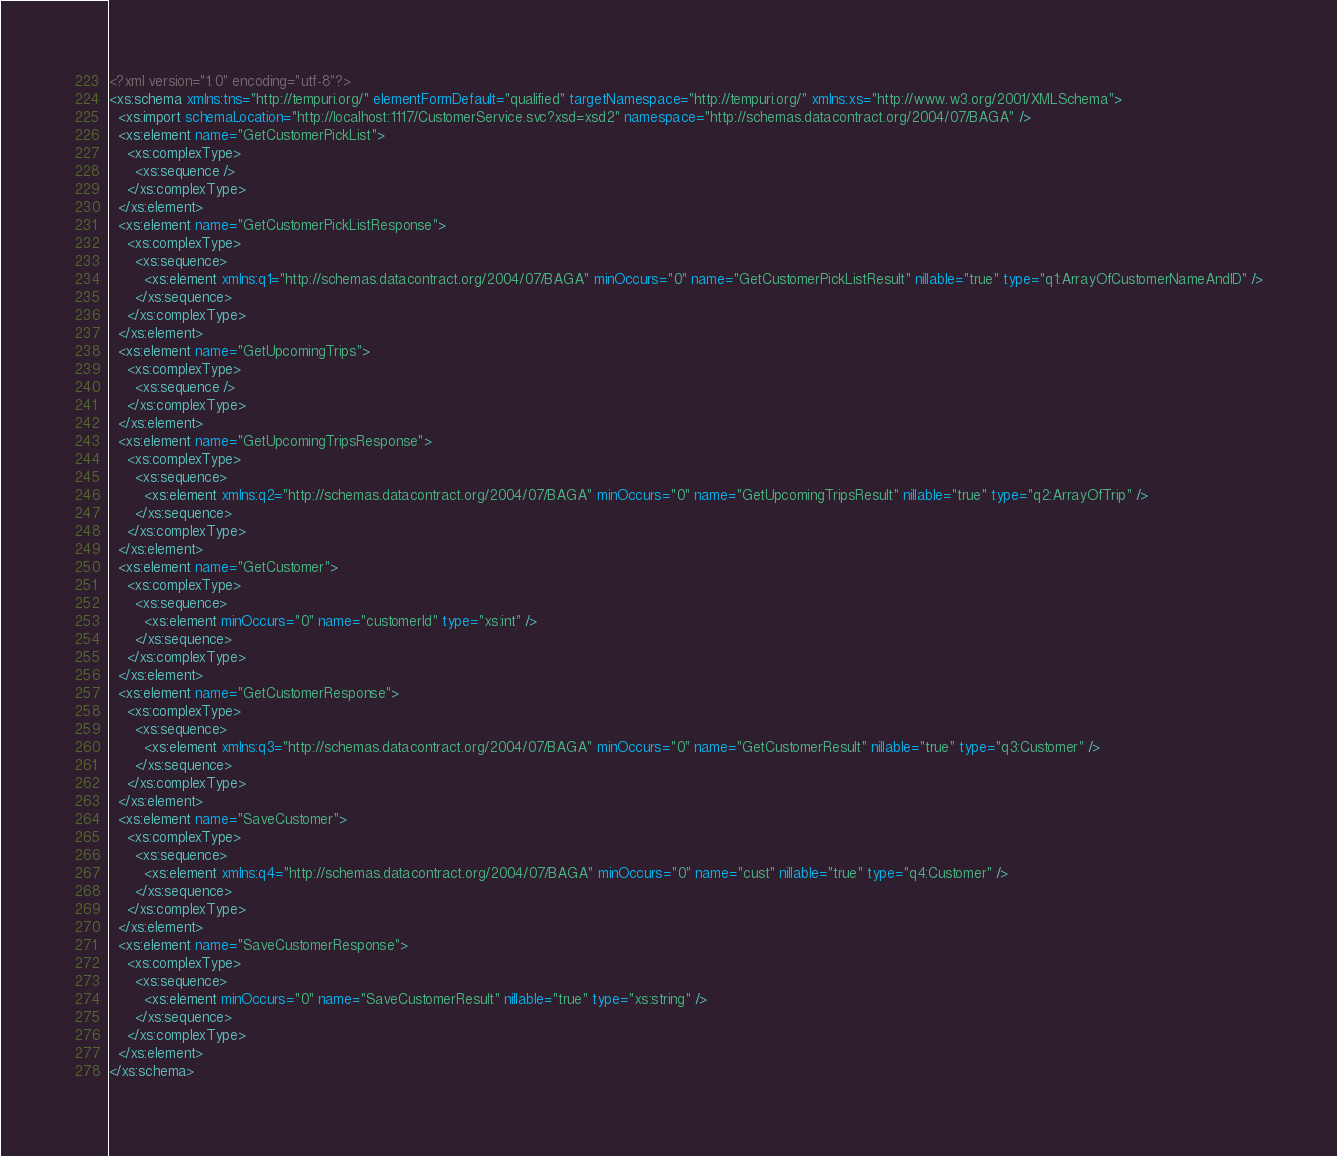<code> <loc_0><loc_0><loc_500><loc_500><_XML_><?xml version="1.0" encoding="utf-8"?>
<xs:schema xmlns:tns="http://tempuri.org/" elementFormDefault="qualified" targetNamespace="http://tempuri.org/" xmlns:xs="http://www.w3.org/2001/XMLSchema">
  <xs:import schemaLocation="http://localhost:1117/CustomerService.svc?xsd=xsd2" namespace="http://schemas.datacontract.org/2004/07/BAGA" />
  <xs:element name="GetCustomerPickList">
    <xs:complexType>
      <xs:sequence />
    </xs:complexType>
  </xs:element>
  <xs:element name="GetCustomerPickListResponse">
    <xs:complexType>
      <xs:sequence>
        <xs:element xmlns:q1="http://schemas.datacontract.org/2004/07/BAGA" minOccurs="0" name="GetCustomerPickListResult" nillable="true" type="q1:ArrayOfCustomerNameAndID" />
      </xs:sequence>
    </xs:complexType>
  </xs:element>
  <xs:element name="GetUpcomingTrips">
    <xs:complexType>
      <xs:sequence />
    </xs:complexType>
  </xs:element>
  <xs:element name="GetUpcomingTripsResponse">
    <xs:complexType>
      <xs:sequence>
        <xs:element xmlns:q2="http://schemas.datacontract.org/2004/07/BAGA" minOccurs="0" name="GetUpcomingTripsResult" nillable="true" type="q2:ArrayOfTrip" />
      </xs:sequence>
    </xs:complexType>
  </xs:element>
  <xs:element name="GetCustomer">
    <xs:complexType>
      <xs:sequence>
        <xs:element minOccurs="0" name="customerId" type="xs:int" />
      </xs:sequence>
    </xs:complexType>
  </xs:element>
  <xs:element name="GetCustomerResponse">
    <xs:complexType>
      <xs:sequence>
        <xs:element xmlns:q3="http://schemas.datacontract.org/2004/07/BAGA" minOccurs="0" name="GetCustomerResult" nillable="true" type="q3:Customer" />
      </xs:sequence>
    </xs:complexType>
  </xs:element>
  <xs:element name="SaveCustomer">
    <xs:complexType>
      <xs:sequence>
        <xs:element xmlns:q4="http://schemas.datacontract.org/2004/07/BAGA" minOccurs="0" name="cust" nillable="true" type="q4:Customer" />
      </xs:sequence>
    </xs:complexType>
  </xs:element>
  <xs:element name="SaveCustomerResponse">
    <xs:complexType>
      <xs:sequence>
        <xs:element minOccurs="0" name="SaveCustomerResult" nillable="true" type="xs:string" />
      </xs:sequence>
    </xs:complexType>
  </xs:element>
</xs:schema></code> 